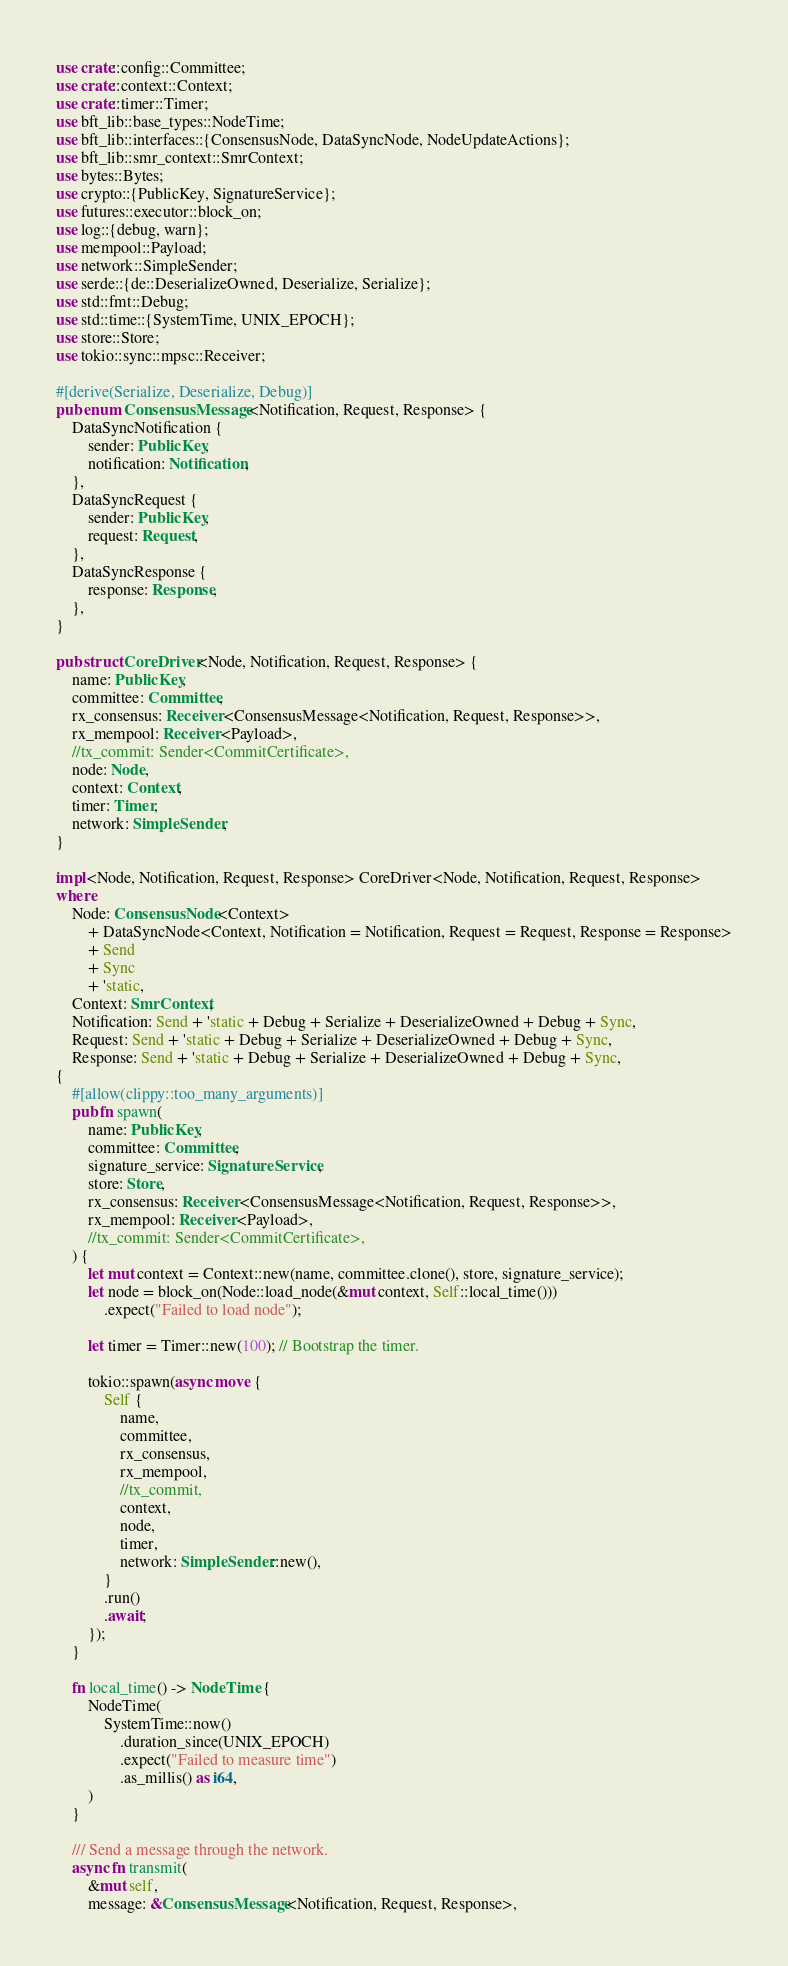<code> <loc_0><loc_0><loc_500><loc_500><_Rust_>use crate::config::Committee;
use crate::context::Context;
use crate::timer::Timer;
use bft_lib::base_types::NodeTime;
use bft_lib::interfaces::{ConsensusNode, DataSyncNode, NodeUpdateActions};
use bft_lib::smr_context::SmrContext;
use bytes::Bytes;
use crypto::{PublicKey, SignatureService};
use futures::executor::block_on;
use log::{debug, warn};
use mempool::Payload;
use network::SimpleSender;
use serde::{de::DeserializeOwned, Deserialize, Serialize};
use std::fmt::Debug;
use std::time::{SystemTime, UNIX_EPOCH};
use store::Store;
use tokio::sync::mpsc::Receiver;

#[derive(Serialize, Deserialize, Debug)]
pub enum ConsensusMessage<Notification, Request, Response> {
    DataSyncNotification {
        sender: PublicKey,
        notification: Notification,
    },
    DataSyncRequest {
        sender: PublicKey,
        request: Request,
    },
    DataSyncResponse {
        response: Response,
    },
}

pub struct CoreDriver<Node, Notification, Request, Response> {
    name: PublicKey,
    committee: Committee,
    rx_consensus: Receiver<ConsensusMessage<Notification, Request, Response>>,
    rx_mempool: Receiver<Payload>,
    //tx_commit: Sender<CommitCertificate>,
    node: Node,
    context: Context,
    timer: Timer,
    network: SimpleSender,
}

impl<Node, Notification, Request, Response> CoreDriver<Node, Notification, Request, Response>
where
    Node: ConsensusNode<Context>
        + DataSyncNode<Context, Notification = Notification, Request = Request, Response = Response>
        + Send
        + Sync
        + 'static,
    Context: SmrContext,
    Notification: Send + 'static + Debug + Serialize + DeserializeOwned + Debug + Sync,
    Request: Send + 'static + Debug + Serialize + DeserializeOwned + Debug + Sync,
    Response: Send + 'static + Debug + Serialize + DeserializeOwned + Debug + Sync,
{
    #[allow(clippy::too_many_arguments)]
    pub fn spawn(
        name: PublicKey,
        committee: Committee,
        signature_service: SignatureService,
        store: Store,
        rx_consensus: Receiver<ConsensusMessage<Notification, Request, Response>>,
        rx_mempool: Receiver<Payload>,
        //tx_commit: Sender<CommitCertificate>,
    ) {
        let mut context = Context::new(name, committee.clone(), store, signature_service);
        let node = block_on(Node::load_node(&mut context, Self::local_time()))
            .expect("Failed to load node");

        let timer = Timer::new(100); // Bootstrap the timer.

        tokio::spawn(async move {
            Self {
                name,
                committee,
                rx_consensus,
                rx_mempool,
                //tx_commit,
                context,
                node,
                timer,
                network: SimpleSender::new(),
            }
            .run()
            .await;
        });
    }

    fn local_time() -> NodeTime {
        NodeTime(
            SystemTime::now()
                .duration_since(UNIX_EPOCH)
                .expect("Failed to measure time")
                .as_millis() as i64,
        )
    }

    /// Send a message through the network.
    async fn transmit(
        &mut self,
        message: &ConsensusMessage<Notification, Request, Response>,</code> 